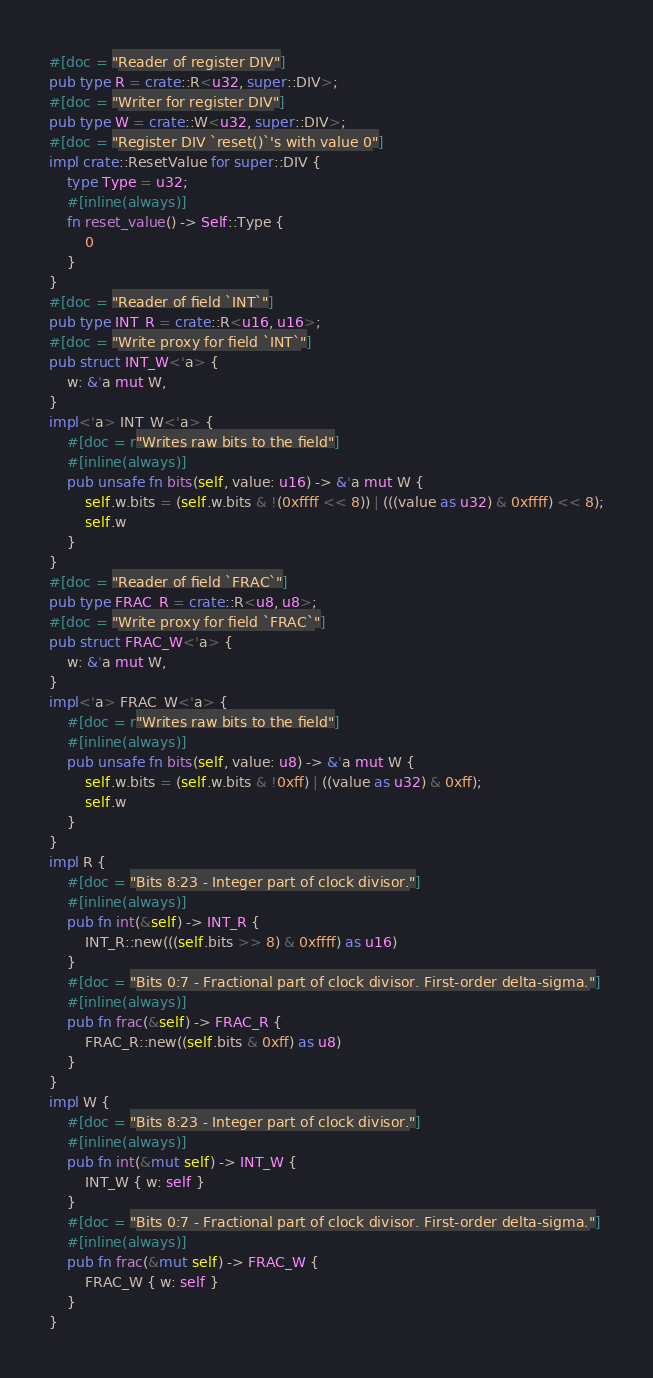Convert code to text. <code><loc_0><loc_0><loc_500><loc_500><_Rust_>#[doc = "Reader of register DIV"]
pub type R = crate::R<u32, super::DIV>;
#[doc = "Writer for register DIV"]
pub type W = crate::W<u32, super::DIV>;
#[doc = "Register DIV `reset()`'s with value 0"]
impl crate::ResetValue for super::DIV {
    type Type = u32;
    #[inline(always)]
    fn reset_value() -> Self::Type {
        0
    }
}
#[doc = "Reader of field `INT`"]
pub type INT_R = crate::R<u16, u16>;
#[doc = "Write proxy for field `INT`"]
pub struct INT_W<'a> {
    w: &'a mut W,
}
impl<'a> INT_W<'a> {
    #[doc = r"Writes raw bits to the field"]
    #[inline(always)]
    pub unsafe fn bits(self, value: u16) -> &'a mut W {
        self.w.bits = (self.w.bits & !(0xffff << 8)) | (((value as u32) & 0xffff) << 8);
        self.w
    }
}
#[doc = "Reader of field `FRAC`"]
pub type FRAC_R = crate::R<u8, u8>;
#[doc = "Write proxy for field `FRAC`"]
pub struct FRAC_W<'a> {
    w: &'a mut W,
}
impl<'a> FRAC_W<'a> {
    #[doc = r"Writes raw bits to the field"]
    #[inline(always)]
    pub unsafe fn bits(self, value: u8) -> &'a mut W {
        self.w.bits = (self.w.bits & !0xff) | ((value as u32) & 0xff);
        self.w
    }
}
impl R {
    #[doc = "Bits 8:23 - Integer part of clock divisor."]
    #[inline(always)]
    pub fn int(&self) -> INT_R {
        INT_R::new(((self.bits >> 8) & 0xffff) as u16)
    }
    #[doc = "Bits 0:7 - Fractional part of clock divisor. First-order delta-sigma."]
    #[inline(always)]
    pub fn frac(&self) -> FRAC_R {
        FRAC_R::new((self.bits & 0xff) as u8)
    }
}
impl W {
    #[doc = "Bits 8:23 - Integer part of clock divisor."]
    #[inline(always)]
    pub fn int(&mut self) -> INT_W {
        INT_W { w: self }
    }
    #[doc = "Bits 0:7 - Fractional part of clock divisor. First-order delta-sigma."]
    #[inline(always)]
    pub fn frac(&mut self) -> FRAC_W {
        FRAC_W { w: self }
    }
}
</code> 